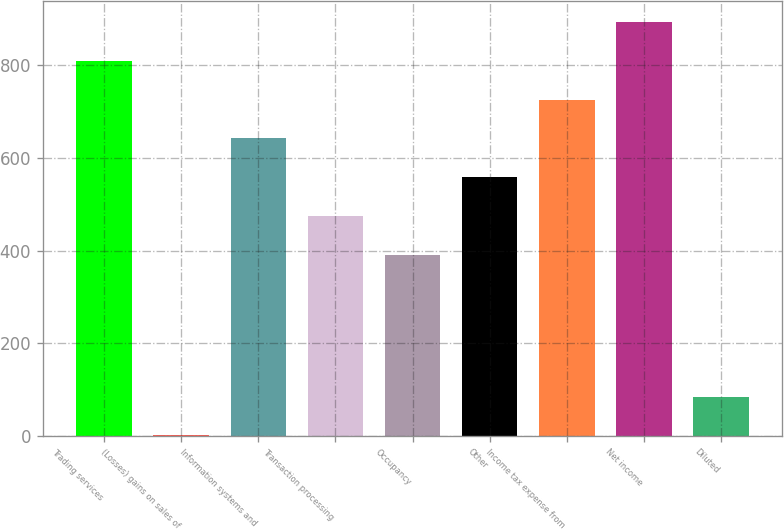<chart> <loc_0><loc_0><loc_500><loc_500><bar_chart><fcel>Trading services<fcel>(Losses) gains on sales of<fcel>Information systems and<fcel>Transaction processing<fcel>Occupancy<fcel>Other<fcel>Income tax expense from<fcel>Net income<fcel>Diluted<nl><fcel>809.5<fcel>1<fcel>642.1<fcel>474.7<fcel>391<fcel>558.4<fcel>725.8<fcel>893.2<fcel>84.7<nl></chart> 